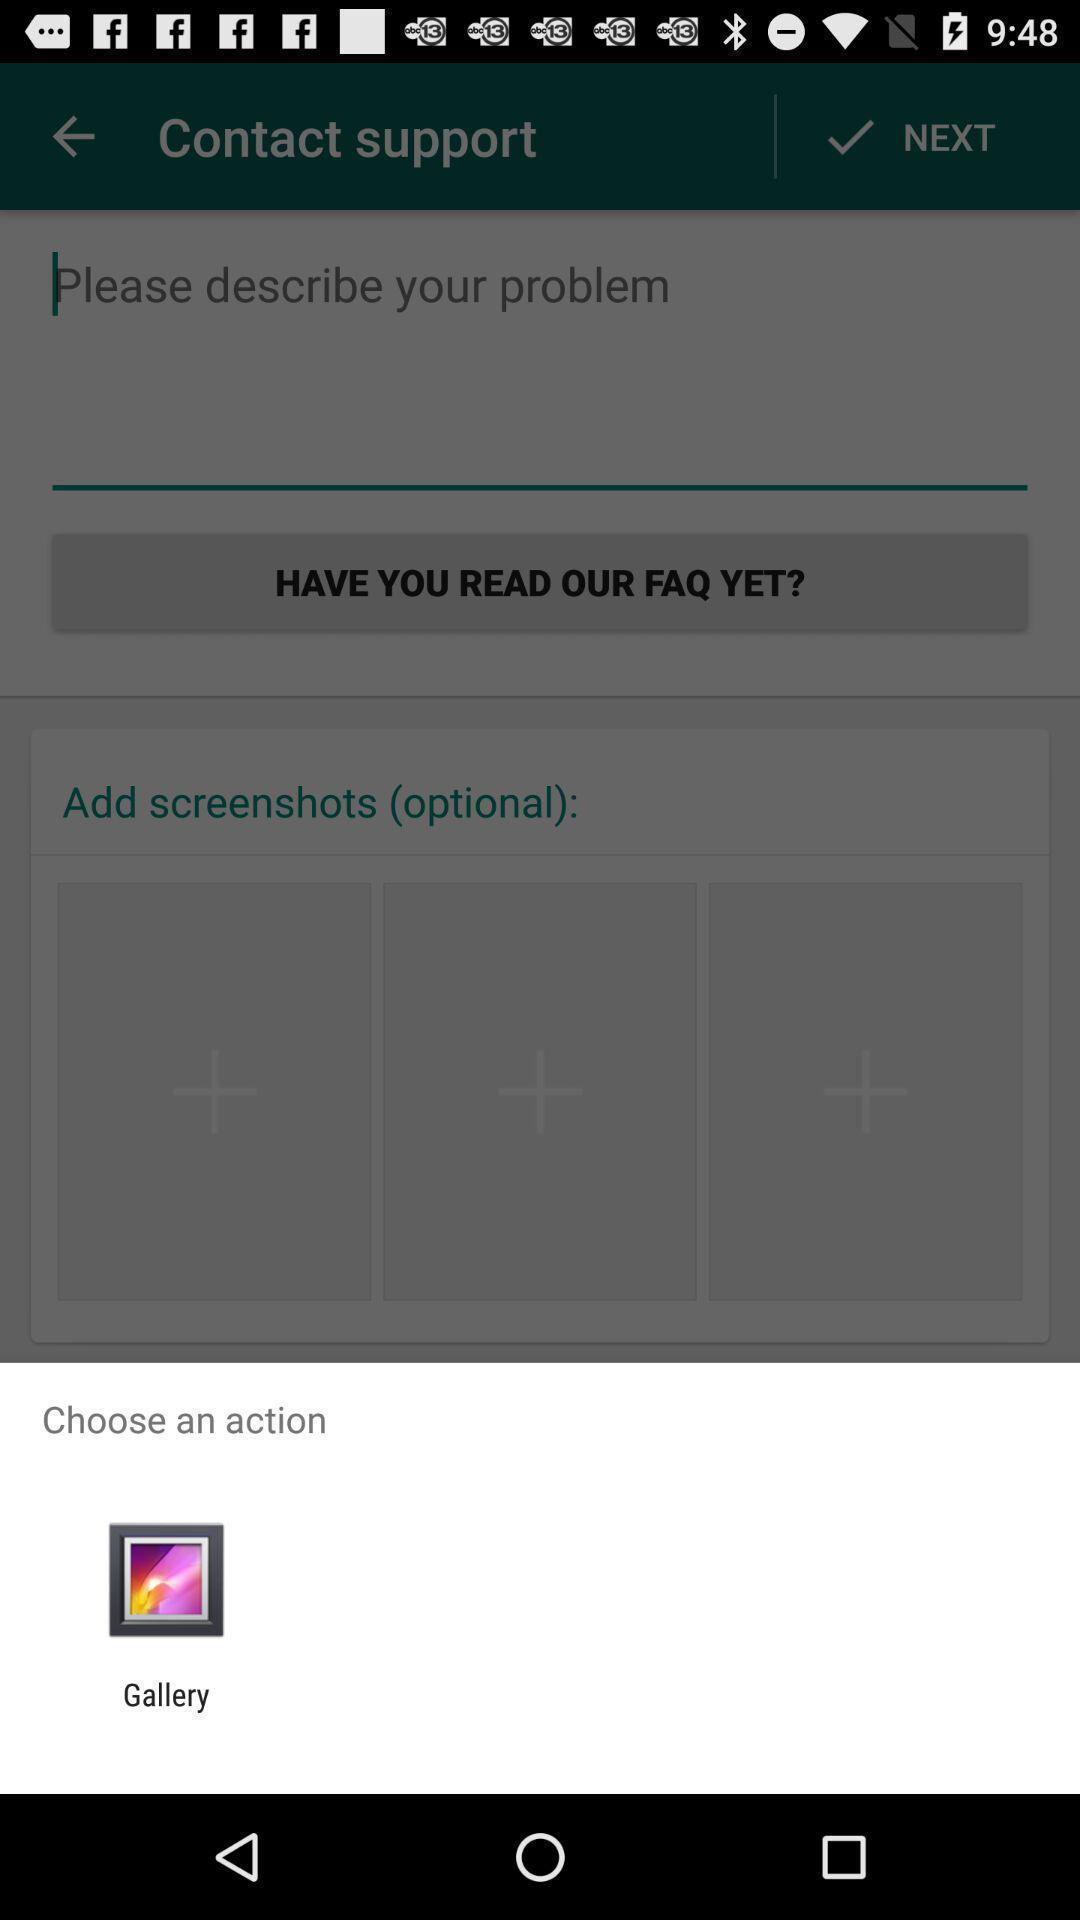Explain the elements present in this screenshot. Popup showing different options to perform action. 